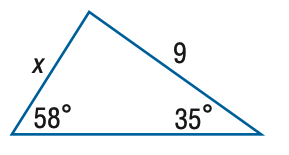Answer the mathemtical geometry problem and directly provide the correct option letter.
Question: Find x. Round the side measure to the nearest tenth.
Choices: A: 5.2 B: 6.1 C: 13.3 D: 15.7 B 